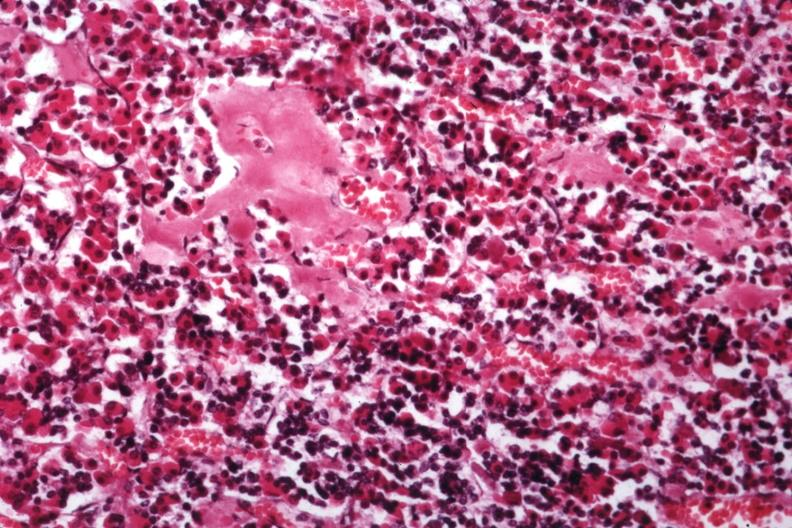what are there from this case in this file 23 yowf amyloid limited to brain?
Answer the question using a single word or phrase. Several slides 